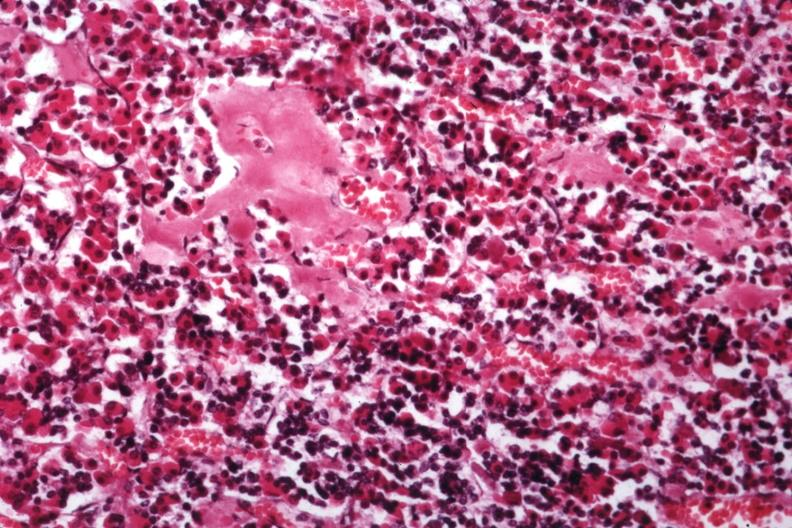what are there from this case in this file 23 yowf amyloid limited to brain?
Answer the question using a single word or phrase. Several slides 